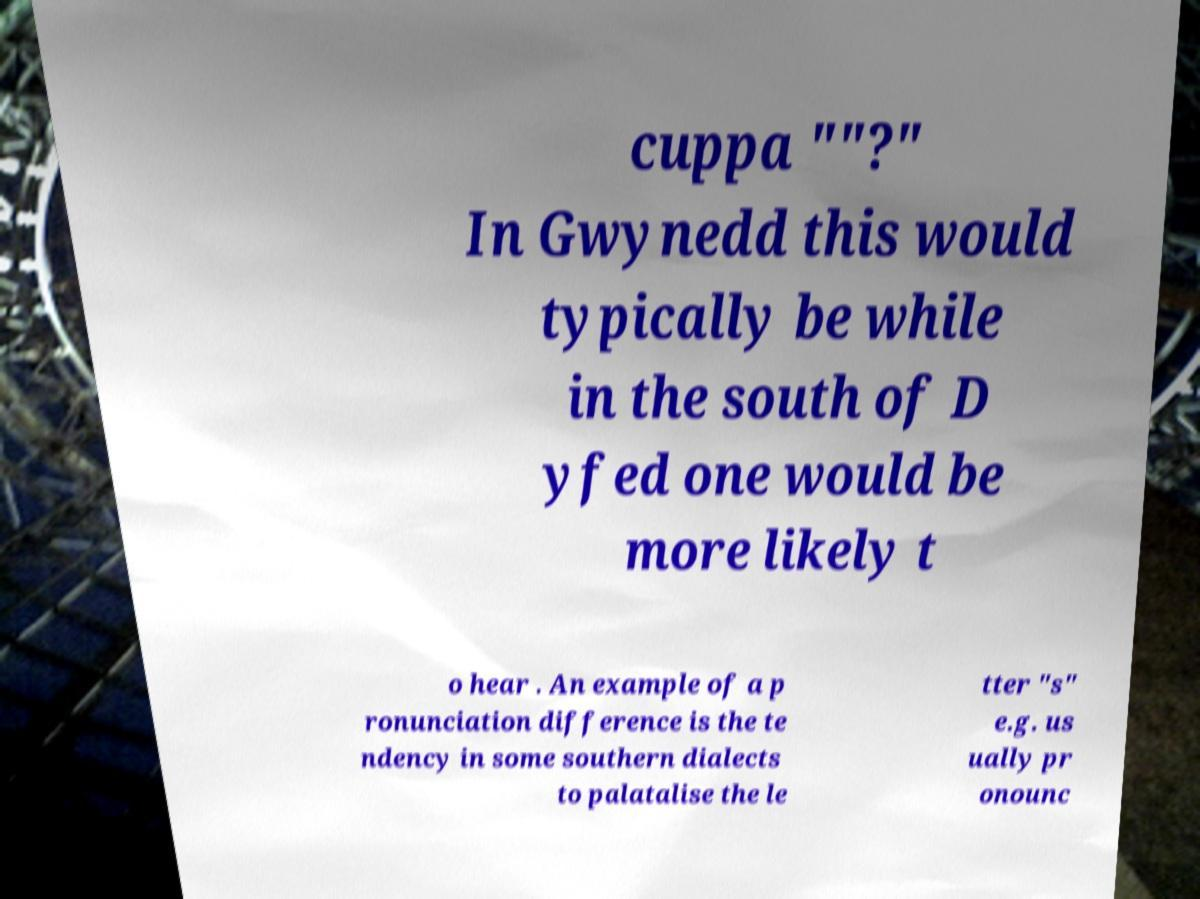Can you read and provide the text displayed in the image?This photo seems to have some interesting text. Can you extract and type it out for me? cuppa ""?" In Gwynedd this would typically be while in the south of D yfed one would be more likely t o hear . An example of a p ronunciation difference is the te ndency in some southern dialects to palatalise the le tter "s" e.g. us ually pr onounc 